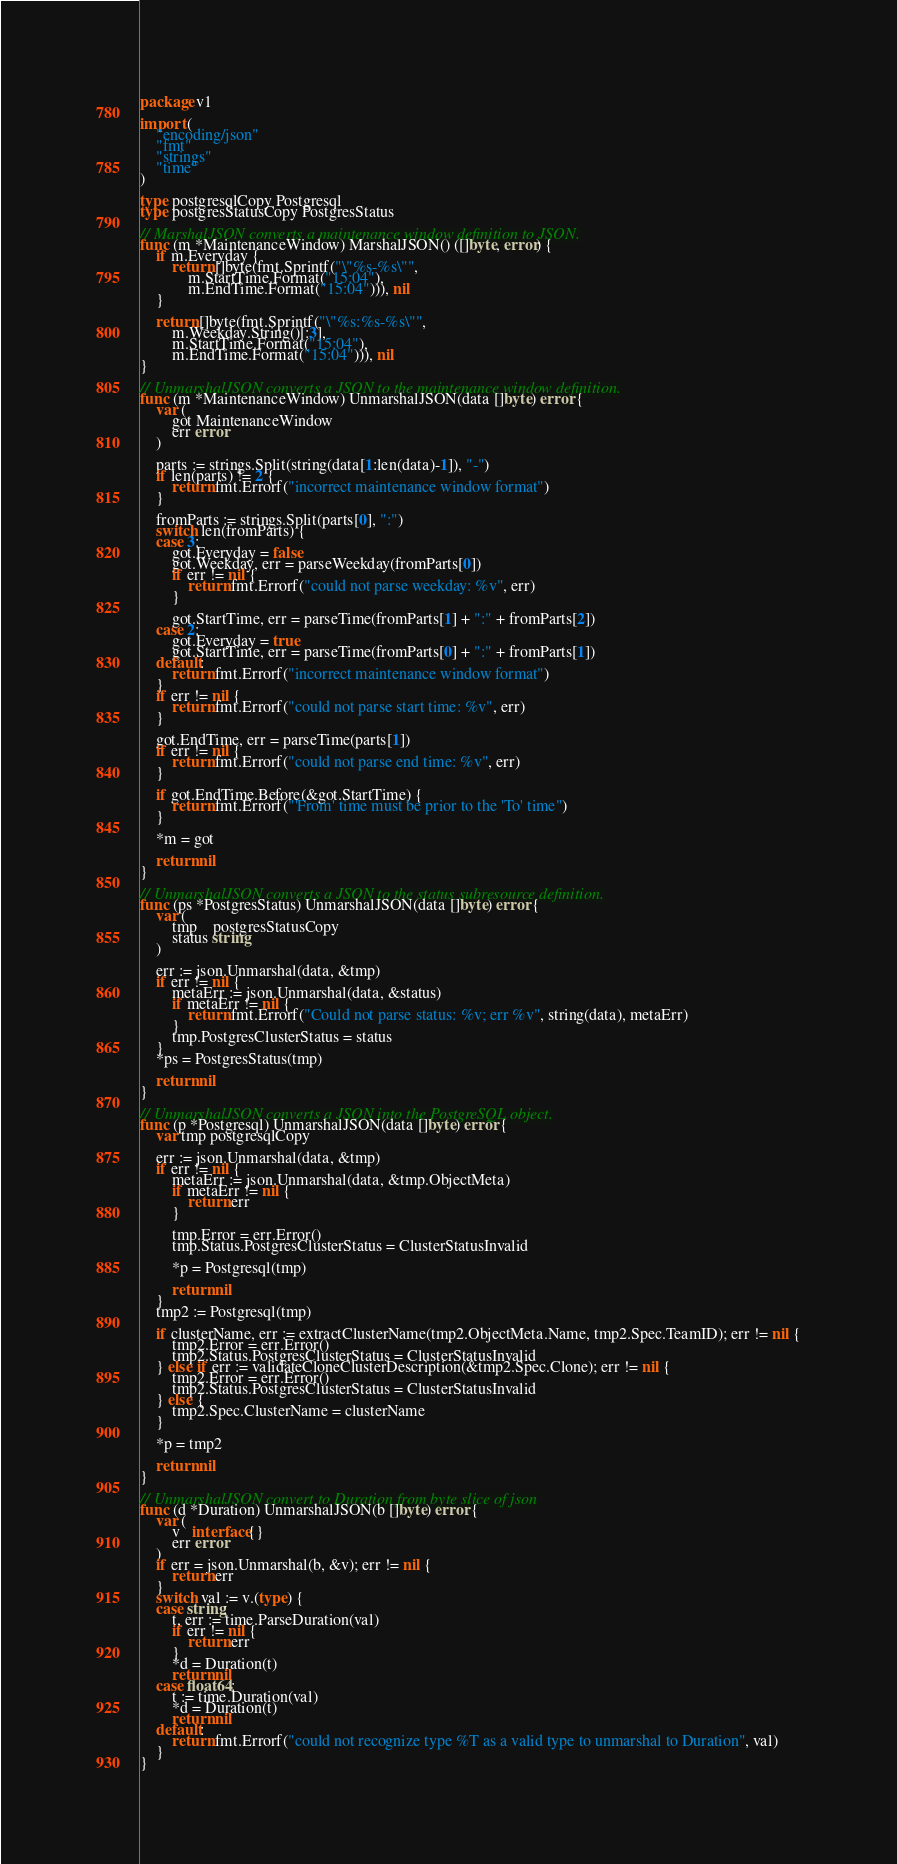<code> <loc_0><loc_0><loc_500><loc_500><_Go_>package v1

import (
	"encoding/json"
	"fmt"
	"strings"
	"time"
)

type postgresqlCopy Postgresql
type postgresStatusCopy PostgresStatus

// MarshalJSON converts a maintenance window definition to JSON.
func (m *MaintenanceWindow) MarshalJSON() ([]byte, error) {
	if m.Everyday {
		return []byte(fmt.Sprintf("\"%s-%s\"",
			m.StartTime.Format("15:04"),
			m.EndTime.Format("15:04"))), nil
	}

	return []byte(fmt.Sprintf("\"%s:%s-%s\"",
		m.Weekday.String()[:3],
		m.StartTime.Format("15:04"),
		m.EndTime.Format("15:04"))), nil
}

// UnmarshalJSON converts a JSON to the maintenance window definition.
func (m *MaintenanceWindow) UnmarshalJSON(data []byte) error {
	var (
		got MaintenanceWindow
		err error
	)

	parts := strings.Split(string(data[1:len(data)-1]), "-")
	if len(parts) != 2 {
		return fmt.Errorf("incorrect maintenance window format")
	}

	fromParts := strings.Split(parts[0], ":")
	switch len(fromParts) {
	case 3:
		got.Everyday = false
		got.Weekday, err = parseWeekday(fromParts[0])
		if err != nil {
			return fmt.Errorf("could not parse weekday: %v", err)
		}

		got.StartTime, err = parseTime(fromParts[1] + ":" + fromParts[2])
	case 2:
		got.Everyday = true
		got.StartTime, err = parseTime(fromParts[0] + ":" + fromParts[1])
	default:
		return fmt.Errorf("incorrect maintenance window format")
	}
	if err != nil {
		return fmt.Errorf("could not parse start time: %v", err)
	}

	got.EndTime, err = parseTime(parts[1])
	if err != nil {
		return fmt.Errorf("could not parse end time: %v", err)
	}

	if got.EndTime.Before(&got.StartTime) {
		return fmt.Errorf("'From' time must be prior to the 'To' time")
	}

	*m = got

	return nil
}

// UnmarshalJSON converts a JSON to the status subresource definition.
func (ps *PostgresStatus) UnmarshalJSON(data []byte) error {
	var (
		tmp    postgresStatusCopy
		status string
	)

	err := json.Unmarshal(data, &tmp)
	if err != nil {
		metaErr := json.Unmarshal(data, &status)
		if metaErr != nil {
			return fmt.Errorf("Could not parse status: %v; err %v", string(data), metaErr)
		}
		tmp.PostgresClusterStatus = status
	}
	*ps = PostgresStatus(tmp)

	return nil
}

// UnmarshalJSON converts a JSON into the PostgreSQL object.
func (p *Postgresql) UnmarshalJSON(data []byte) error {
	var tmp postgresqlCopy

	err := json.Unmarshal(data, &tmp)
	if err != nil {
		metaErr := json.Unmarshal(data, &tmp.ObjectMeta)
		if metaErr != nil {
			return err
		}

		tmp.Error = err.Error()
		tmp.Status.PostgresClusterStatus = ClusterStatusInvalid

		*p = Postgresql(tmp)

		return nil
	}
	tmp2 := Postgresql(tmp)

	if clusterName, err := extractClusterName(tmp2.ObjectMeta.Name, tmp2.Spec.TeamID); err != nil {
		tmp2.Error = err.Error()
		tmp2.Status.PostgresClusterStatus = ClusterStatusInvalid
	} else if err := validateCloneClusterDescription(&tmp2.Spec.Clone); err != nil {
		tmp2.Error = err.Error()
		tmp2.Status.PostgresClusterStatus = ClusterStatusInvalid
	} else {
		tmp2.Spec.ClusterName = clusterName
	}

	*p = tmp2

	return nil
}

// UnmarshalJSON convert to Duration from byte slice of json
func (d *Duration) UnmarshalJSON(b []byte) error {
	var (
		v   interface{}
		err error
	)
	if err = json.Unmarshal(b, &v); err != nil {
		return err
	}
	switch val := v.(type) {
	case string:
		t, err := time.ParseDuration(val)
		if err != nil {
			return err
		}
		*d = Duration(t)
		return nil
	case float64:
		t := time.Duration(val)
		*d = Duration(t)
		return nil
	default:
		return fmt.Errorf("could not recognize type %T as a valid type to unmarshal to Duration", val)
	}
}
</code> 